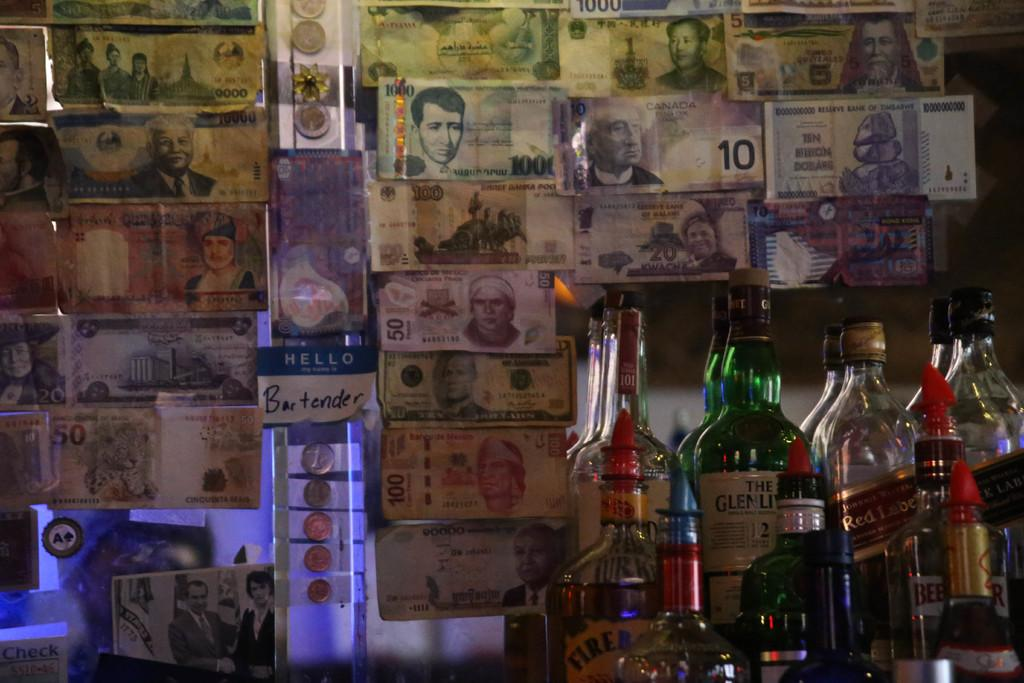What objects are placed on the mirror in the image? There are bottles and currency present on the mirror. Is there any other item on the mirror besides the bottles and currency? Yes, there is a picture on the mirror. What type of war is depicted in the image? There is no depiction of a war in the image; it features bottles, currency, and a picture on a mirror. What border can be seen in the image? There is no border present in the image. 